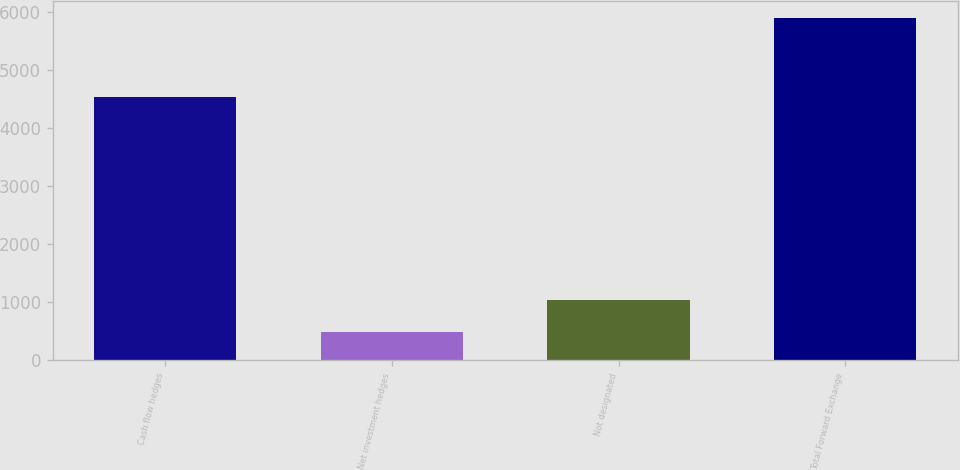Convert chart. <chart><loc_0><loc_0><loc_500><loc_500><bar_chart><fcel>Cash flow hedges<fcel>Net investment hedges<fcel>Not designated<fcel>Total Forward Exchange<nl><fcel>4543.8<fcel>491.3<fcel>1032.01<fcel>5898.4<nl></chart> 